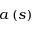Convert formula to latex. <formula><loc_0><loc_0><loc_500><loc_500>a \left ( s \right )</formula> 